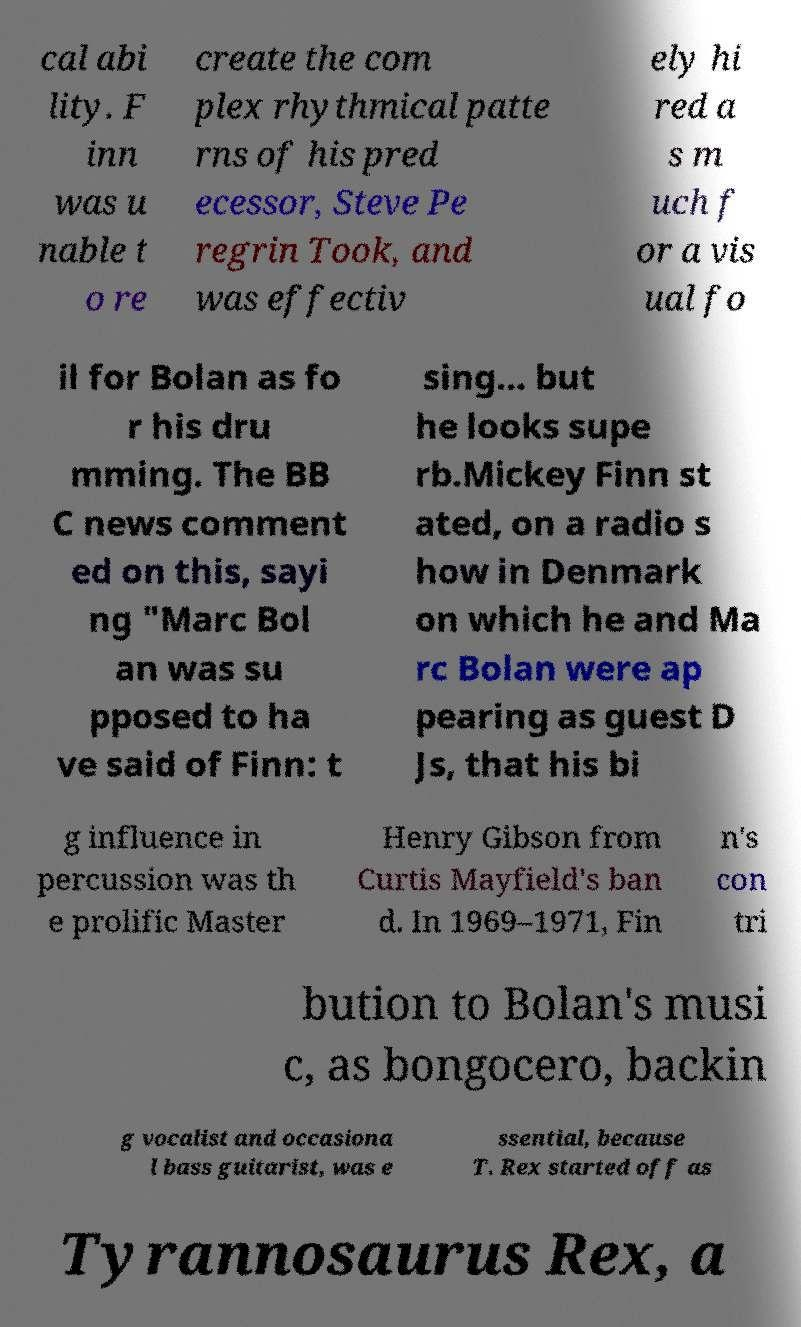Could you extract and type out the text from this image? cal abi lity. F inn was u nable t o re create the com plex rhythmical patte rns of his pred ecessor, Steve Pe regrin Took, and was effectiv ely hi red a s m uch f or a vis ual fo il for Bolan as fo r his dru mming. The BB C news comment ed on this, sayi ng "Marc Bol an was su pposed to ha ve said of Finn: t sing... but he looks supe rb.Mickey Finn st ated, on a radio s how in Denmark on which he and Ma rc Bolan were ap pearing as guest D Js, that his bi g influence in percussion was th e prolific Master Henry Gibson from Curtis Mayfield's ban d. In 1969–1971, Fin n's con tri bution to Bolan's musi c, as bongocero, backin g vocalist and occasiona l bass guitarist, was e ssential, because T. Rex started off as Tyrannosaurus Rex, a 